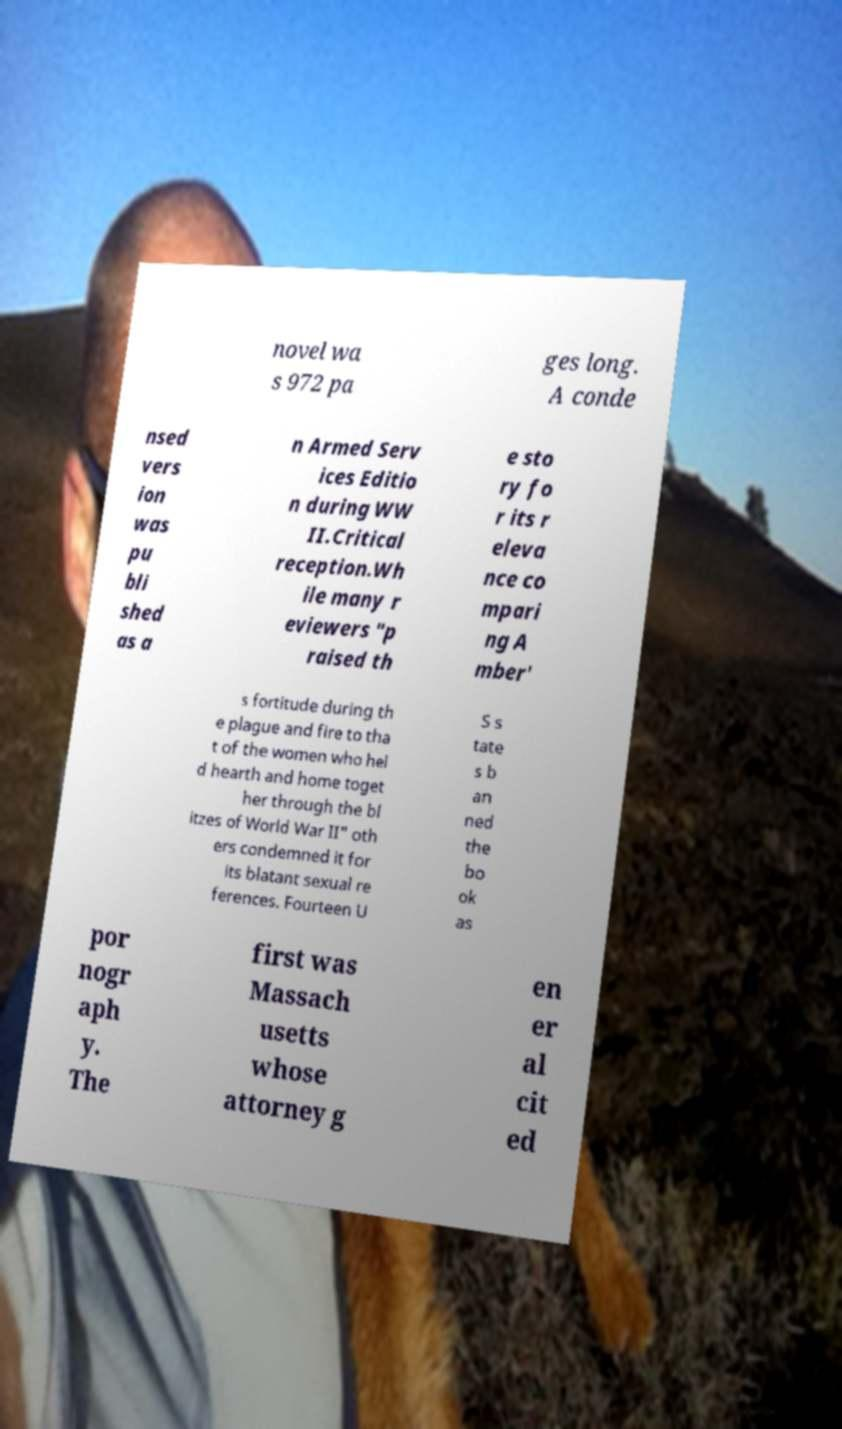Can you accurately transcribe the text from the provided image for me? novel wa s 972 pa ges long. A conde nsed vers ion was pu bli shed as a n Armed Serv ices Editio n during WW II.Critical reception.Wh ile many r eviewers "p raised th e sto ry fo r its r eleva nce co mpari ng A mber' s fortitude during th e plague and fire to tha t of the women who hel d hearth and home toget her through the bl itzes of World War II" oth ers condemned it for its blatant sexual re ferences. Fourteen U S s tate s b an ned the bo ok as por nogr aph y. The first was Massach usetts whose attorney g en er al cit ed 